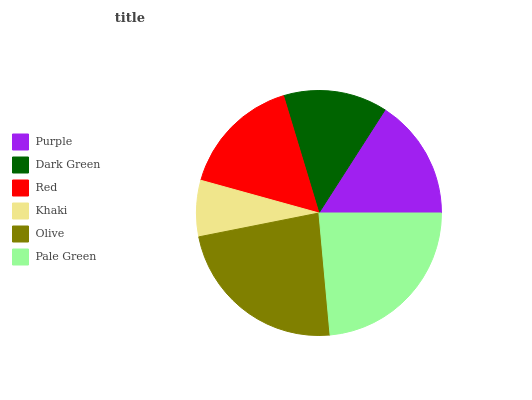Is Khaki the minimum?
Answer yes or no. Yes. Is Pale Green the maximum?
Answer yes or no. Yes. Is Dark Green the minimum?
Answer yes or no. No. Is Dark Green the maximum?
Answer yes or no. No. Is Purple greater than Dark Green?
Answer yes or no. Yes. Is Dark Green less than Purple?
Answer yes or no. Yes. Is Dark Green greater than Purple?
Answer yes or no. No. Is Purple less than Dark Green?
Answer yes or no. No. Is Red the high median?
Answer yes or no. Yes. Is Purple the low median?
Answer yes or no. Yes. Is Olive the high median?
Answer yes or no. No. Is Dark Green the low median?
Answer yes or no. No. 